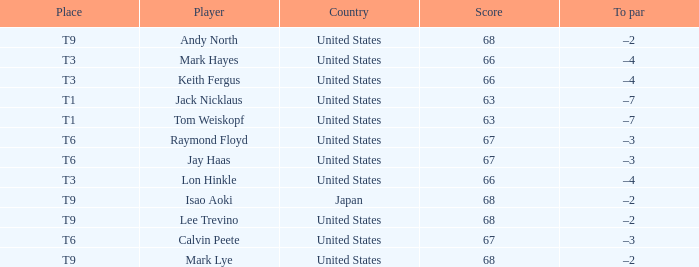What is To Par, when Place is "T9", and when Player is "Lee Trevino"? –2. Could you parse the entire table? {'header': ['Place', 'Player', 'Country', 'Score', 'To par'], 'rows': [['T9', 'Andy North', 'United States', '68', '–2'], ['T3', 'Mark Hayes', 'United States', '66', '–4'], ['T3', 'Keith Fergus', 'United States', '66', '–4'], ['T1', 'Jack Nicklaus', 'United States', '63', '–7'], ['T1', 'Tom Weiskopf', 'United States', '63', '–7'], ['T6', 'Raymond Floyd', 'United States', '67', '–3'], ['T6', 'Jay Haas', 'United States', '67', '–3'], ['T3', 'Lon Hinkle', 'United States', '66', '–4'], ['T9', 'Isao Aoki', 'Japan', '68', '–2'], ['T9', 'Lee Trevino', 'United States', '68', '–2'], ['T6', 'Calvin Peete', 'United States', '67', '–3'], ['T9', 'Mark Lye', 'United States', '68', '–2']]} 